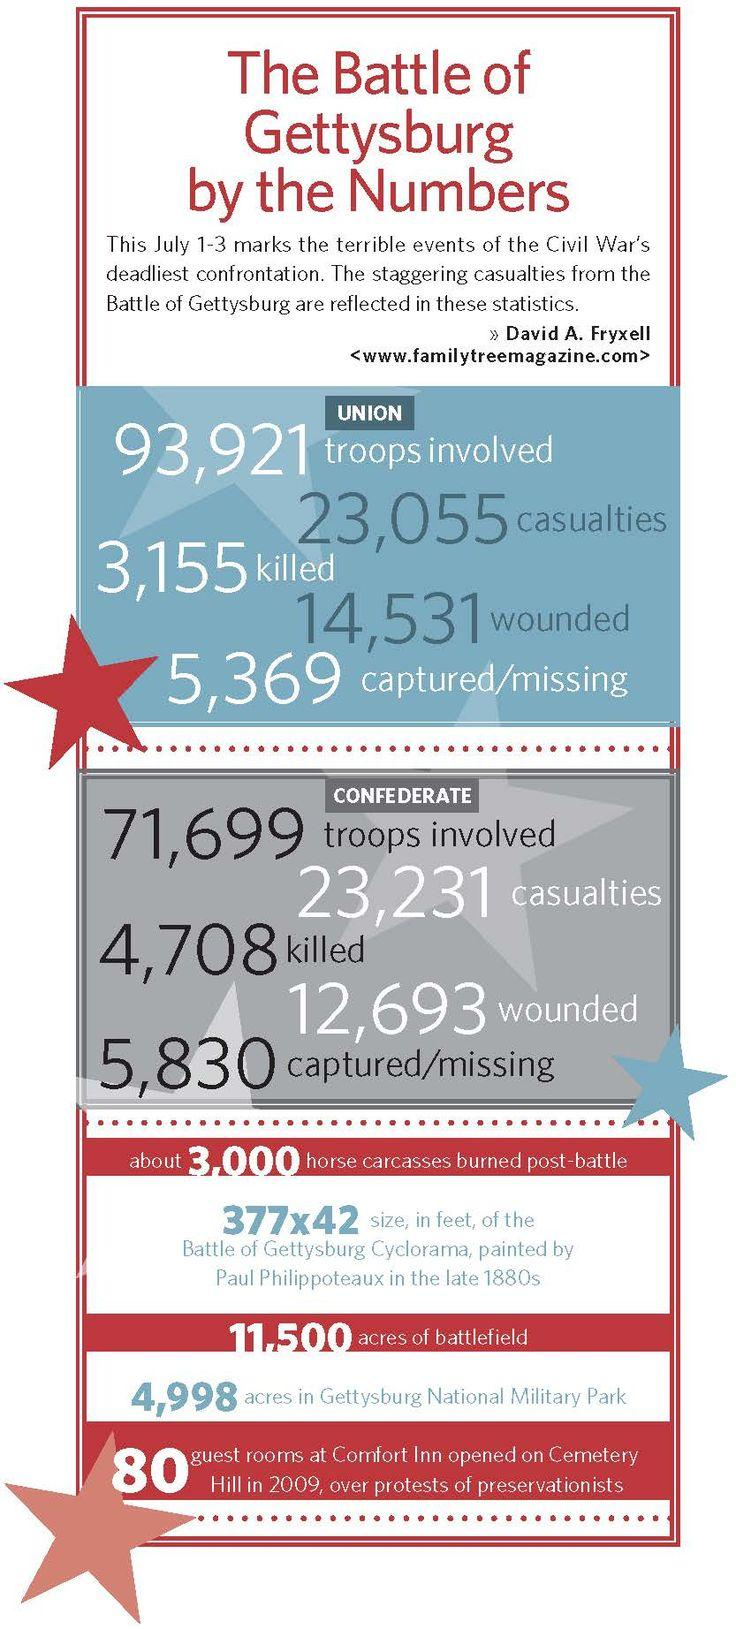List a handful of essential elements in this visual. During the Battle of Gettysburg, a total of 4,708 people on the Confederate side lost their lives. During the Battle of Gettysburg, a total of 5,369 people on the Union side were either caught or not found. The number of soldiers who were killed, injured, or captured on the Confederate side was 23,231. During the Battle of Gettysburg, a total of 12,693 people on the Confederate side were injured. The total number of soldiers who were murdered, injured, or captured on the Union side was 23,055. 